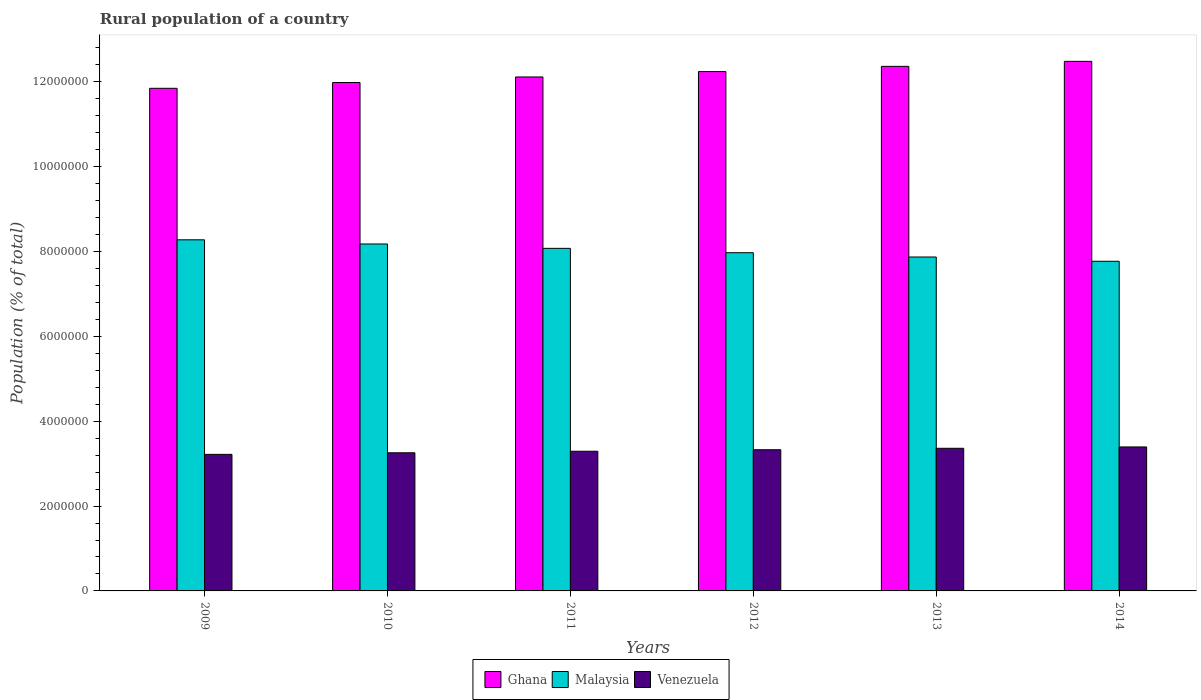How many different coloured bars are there?
Give a very brief answer. 3. How many groups of bars are there?
Ensure brevity in your answer.  6. Are the number of bars per tick equal to the number of legend labels?
Ensure brevity in your answer.  Yes. Are the number of bars on each tick of the X-axis equal?
Keep it short and to the point. Yes. How many bars are there on the 5th tick from the left?
Offer a terse response. 3. How many bars are there on the 6th tick from the right?
Provide a succinct answer. 3. What is the label of the 6th group of bars from the left?
Keep it short and to the point. 2014. What is the rural population in Venezuela in 2011?
Your answer should be compact. 3.29e+06. Across all years, what is the maximum rural population in Malaysia?
Make the answer very short. 8.28e+06. Across all years, what is the minimum rural population in Ghana?
Make the answer very short. 1.18e+07. In which year was the rural population in Malaysia maximum?
Offer a very short reply. 2009. What is the total rural population in Ghana in the graph?
Ensure brevity in your answer.  7.30e+07. What is the difference between the rural population in Ghana in 2009 and that in 2011?
Provide a short and direct response. -2.68e+05. What is the difference between the rural population in Venezuela in 2010 and the rural population in Malaysia in 2009?
Keep it short and to the point. -5.02e+06. What is the average rural population in Venezuela per year?
Provide a succinct answer. 3.31e+06. In the year 2009, what is the difference between the rural population in Venezuela and rural population in Ghana?
Make the answer very short. -8.63e+06. In how many years, is the rural population in Malaysia greater than 9600000 %?
Provide a succinct answer. 0. What is the ratio of the rural population in Venezuela in 2011 to that in 2012?
Provide a succinct answer. 0.99. What is the difference between the highest and the second highest rural population in Malaysia?
Make the answer very short. 9.82e+04. What is the difference between the highest and the lowest rural population in Ghana?
Give a very brief answer. 6.35e+05. Is the sum of the rural population in Venezuela in 2011 and 2014 greater than the maximum rural population in Malaysia across all years?
Give a very brief answer. No. What does the 3rd bar from the left in 2012 represents?
Your answer should be very brief. Venezuela. What does the 2nd bar from the right in 2009 represents?
Ensure brevity in your answer.  Malaysia. Is it the case that in every year, the sum of the rural population in Ghana and rural population in Malaysia is greater than the rural population in Venezuela?
Give a very brief answer. Yes. How many years are there in the graph?
Keep it short and to the point. 6. What is the difference between two consecutive major ticks on the Y-axis?
Keep it short and to the point. 2.00e+06. Does the graph contain any zero values?
Give a very brief answer. No. Does the graph contain grids?
Ensure brevity in your answer.  No. How many legend labels are there?
Offer a very short reply. 3. What is the title of the graph?
Provide a succinct answer. Rural population of a country. What is the label or title of the Y-axis?
Your answer should be very brief. Population (% of total). What is the Population (% of total) of Ghana in 2009?
Provide a short and direct response. 1.18e+07. What is the Population (% of total) in Malaysia in 2009?
Make the answer very short. 8.28e+06. What is the Population (% of total) in Venezuela in 2009?
Make the answer very short. 3.22e+06. What is the Population (% of total) of Ghana in 2010?
Ensure brevity in your answer.  1.20e+07. What is the Population (% of total) in Malaysia in 2010?
Provide a succinct answer. 8.18e+06. What is the Population (% of total) in Venezuela in 2010?
Make the answer very short. 3.26e+06. What is the Population (% of total) in Ghana in 2011?
Provide a succinct answer. 1.21e+07. What is the Population (% of total) of Malaysia in 2011?
Keep it short and to the point. 8.08e+06. What is the Population (% of total) in Venezuela in 2011?
Make the answer very short. 3.29e+06. What is the Population (% of total) of Ghana in 2012?
Your answer should be very brief. 1.22e+07. What is the Population (% of total) of Malaysia in 2012?
Give a very brief answer. 7.97e+06. What is the Population (% of total) of Venezuela in 2012?
Provide a short and direct response. 3.33e+06. What is the Population (% of total) of Ghana in 2013?
Keep it short and to the point. 1.24e+07. What is the Population (% of total) of Malaysia in 2013?
Your response must be concise. 7.87e+06. What is the Population (% of total) in Venezuela in 2013?
Your answer should be compact. 3.36e+06. What is the Population (% of total) in Ghana in 2014?
Offer a very short reply. 1.25e+07. What is the Population (% of total) of Malaysia in 2014?
Make the answer very short. 7.77e+06. What is the Population (% of total) in Venezuela in 2014?
Provide a short and direct response. 3.39e+06. Across all years, what is the maximum Population (% of total) in Ghana?
Offer a terse response. 1.25e+07. Across all years, what is the maximum Population (% of total) in Malaysia?
Give a very brief answer. 8.28e+06. Across all years, what is the maximum Population (% of total) in Venezuela?
Your answer should be compact. 3.39e+06. Across all years, what is the minimum Population (% of total) in Ghana?
Give a very brief answer. 1.18e+07. Across all years, what is the minimum Population (% of total) of Malaysia?
Offer a terse response. 7.77e+06. Across all years, what is the minimum Population (% of total) in Venezuela?
Your answer should be very brief. 3.22e+06. What is the total Population (% of total) in Ghana in the graph?
Your response must be concise. 7.30e+07. What is the total Population (% of total) in Malaysia in the graph?
Your answer should be very brief. 4.82e+07. What is the total Population (% of total) of Venezuela in the graph?
Make the answer very short. 1.99e+07. What is the difference between the Population (% of total) of Ghana in 2009 and that in 2010?
Keep it short and to the point. -1.36e+05. What is the difference between the Population (% of total) of Malaysia in 2009 and that in 2010?
Provide a short and direct response. 9.82e+04. What is the difference between the Population (% of total) in Venezuela in 2009 and that in 2010?
Ensure brevity in your answer.  -3.74e+04. What is the difference between the Population (% of total) in Ghana in 2009 and that in 2011?
Provide a succinct answer. -2.68e+05. What is the difference between the Population (% of total) in Malaysia in 2009 and that in 2011?
Your answer should be very brief. 2.01e+05. What is the difference between the Population (% of total) in Venezuela in 2009 and that in 2011?
Your answer should be compact. -7.38e+04. What is the difference between the Population (% of total) of Ghana in 2009 and that in 2012?
Offer a terse response. -3.95e+05. What is the difference between the Population (% of total) in Malaysia in 2009 and that in 2012?
Your answer should be compact. 3.04e+05. What is the difference between the Population (% of total) of Venezuela in 2009 and that in 2012?
Your response must be concise. -1.09e+05. What is the difference between the Population (% of total) of Ghana in 2009 and that in 2013?
Your answer should be very brief. -5.17e+05. What is the difference between the Population (% of total) in Malaysia in 2009 and that in 2013?
Your answer should be very brief. 4.06e+05. What is the difference between the Population (% of total) in Venezuela in 2009 and that in 2013?
Make the answer very short. -1.43e+05. What is the difference between the Population (% of total) in Ghana in 2009 and that in 2014?
Give a very brief answer. -6.35e+05. What is the difference between the Population (% of total) in Malaysia in 2009 and that in 2014?
Ensure brevity in your answer.  5.06e+05. What is the difference between the Population (% of total) of Venezuela in 2009 and that in 2014?
Your answer should be compact. -1.75e+05. What is the difference between the Population (% of total) of Ghana in 2010 and that in 2011?
Your answer should be compact. -1.31e+05. What is the difference between the Population (% of total) of Malaysia in 2010 and that in 2011?
Give a very brief answer. 1.03e+05. What is the difference between the Population (% of total) in Venezuela in 2010 and that in 2011?
Your response must be concise. -3.64e+04. What is the difference between the Population (% of total) in Ghana in 2010 and that in 2012?
Provide a succinct answer. -2.58e+05. What is the difference between the Population (% of total) in Malaysia in 2010 and that in 2012?
Provide a short and direct response. 2.06e+05. What is the difference between the Population (% of total) of Venezuela in 2010 and that in 2012?
Your response must be concise. -7.19e+04. What is the difference between the Population (% of total) of Ghana in 2010 and that in 2013?
Your response must be concise. -3.81e+05. What is the difference between the Population (% of total) of Malaysia in 2010 and that in 2013?
Ensure brevity in your answer.  3.07e+05. What is the difference between the Population (% of total) of Venezuela in 2010 and that in 2013?
Ensure brevity in your answer.  -1.06e+05. What is the difference between the Population (% of total) in Ghana in 2010 and that in 2014?
Your response must be concise. -4.99e+05. What is the difference between the Population (% of total) of Malaysia in 2010 and that in 2014?
Your response must be concise. 4.08e+05. What is the difference between the Population (% of total) of Venezuela in 2010 and that in 2014?
Your answer should be very brief. -1.38e+05. What is the difference between the Population (% of total) in Ghana in 2011 and that in 2012?
Provide a short and direct response. -1.27e+05. What is the difference between the Population (% of total) of Malaysia in 2011 and that in 2012?
Your answer should be very brief. 1.03e+05. What is the difference between the Population (% of total) in Venezuela in 2011 and that in 2012?
Provide a succinct answer. -3.55e+04. What is the difference between the Population (% of total) in Ghana in 2011 and that in 2013?
Provide a succinct answer. -2.50e+05. What is the difference between the Population (% of total) of Malaysia in 2011 and that in 2013?
Your answer should be very brief. 2.04e+05. What is the difference between the Population (% of total) in Venezuela in 2011 and that in 2013?
Provide a short and direct response. -6.95e+04. What is the difference between the Population (% of total) in Ghana in 2011 and that in 2014?
Make the answer very short. -3.68e+05. What is the difference between the Population (% of total) of Malaysia in 2011 and that in 2014?
Provide a short and direct response. 3.05e+05. What is the difference between the Population (% of total) in Venezuela in 2011 and that in 2014?
Make the answer very short. -1.01e+05. What is the difference between the Population (% of total) of Ghana in 2012 and that in 2013?
Your answer should be very brief. -1.23e+05. What is the difference between the Population (% of total) of Malaysia in 2012 and that in 2013?
Your response must be concise. 1.02e+05. What is the difference between the Population (% of total) of Venezuela in 2012 and that in 2013?
Offer a very short reply. -3.40e+04. What is the difference between the Population (% of total) in Ghana in 2012 and that in 2014?
Give a very brief answer. -2.41e+05. What is the difference between the Population (% of total) in Malaysia in 2012 and that in 2014?
Keep it short and to the point. 2.02e+05. What is the difference between the Population (% of total) of Venezuela in 2012 and that in 2014?
Offer a very short reply. -6.60e+04. What is the difference between the Population (% of total) of Ghana in 2013 and that in 2014?
Offer a very short reply. -1.18e+05. What is the difference between the Population (% of total) in Malaysia in 2013 and that in 2014?
Your answer should be compact. 1.00e+05. What is the difference between the Population (% of total) of Venezuela in 2013 and that in 2014?
Your answer should be compact. -3.20e+04. What is the difference between the Population (% of total) of Ghana in 2009 and the Population (% of total) of Malaysia in 2010?
Provide a short and direct response. 3.67e+06. What is the difference between the Population (% of total) in Ghana in 2009 and the Population (% of total) in Venezuela in 2010?
Keep it short and to the point. 8.59e+06. What is the difference between the Population (% of total) in Malaysia in 2009 and the Population (% of total) in Venezuela in 2010?
Your response must be concise. 5.02e+06. What is the difference between the Population (% of total) in Ghana in 2009 and the Population (% of total) in Malaysia in 2011?
Give a very brief answer. 3.77e+06. What is the difference between the Population (% of total) in Ghana in 2009 and the Population (% of total) in Venezuela in 2011?
Ensure brevity in your answer.  8.56e+06. What is the difference between the Population (% of total) in Malaysia in 2009 and the Population (% of total) in Venezuela in 2011?
Give a very brief answer. 4.98e+06. What is the difference between the Population (% of total) of Ghana in 2009 and the Population (% of total) of Malaysia in 2012?
Offer a very short reply. 3.88e+06. What is the difference between the Population (% of total) in Ghana in 2009 and the Population (% of total) in Venezuela in 2012?
Your answer should be very brief. 8.52e+06. What is the difference between the Population (% of total) in Malaysia in 2009 and the Population (% of total) in Venezuela in 2012?
Your answer should be very brief. 4.95e+06. What is the difference between the Population (% of total) of Ghana in 2009 and the Population (% of total) of Malaysia in 2013?
Your answer should be compact. 3.98e+06. What is the difference between the Population (% of total) of Ghana in 2009 and the Population (% of total) of Venezuela in 2013?
Make the answer very short. 8.49e+06. What is the difference between the Population (% of total) of Malaysia in 2009 and the Population (% of total) of Venezuela in 2013?
Keep it short and to the point. 4.92e+06. What is the difference between the Population (% of total) of Ghana in 2009 and the Population (% of total) of Malaysia in 2014?
Offer a terse response. 4.08e+06. What is the difference between the Population (% of total) of Ghana in 2009 and the Population (% of total) of Venezuela in 2014?
Your response must be concise. 8.45e+06. What is the difference between the Population (% of total) of Malaysia in 2009 and the Population (% of total) of Venezuela in 2014?
Offer a terse response. 4.88e+06. What is the difference between the Population (% of total) of Ghana in 2010 and the Population (% of total) of Malaysia in 2011?
Your answer should be very brief. 3.91e+06. What is the difference between the Population (% of total) of Ghana in 2010 and the Population (% of total) of Venezuela in 2011?
Offer a terse response. 8.69e+06. What is the difference between the Population (% of total) of Malaysia in 2010 and the Population (% of total) of Venezuela in 2011?
Give a very brief answer. 4.89e+06. What is the difference between the Population (% of total) of Ghana in 2010 and the Population (% of total) of Malaysia in 2012?
Provide a succinct answer. 4.01e+06. What is the difference between the Population (% of total) of Ghana in 2010 and the Population (% of total) of Venezuela in 2012?
Your answer should be very brief. 8.66e+06. What is the difference between the Population (% of total) of Malaysia in 2010 and the Population (% of total) of Venezuela in 2012?
Your answer should be very brief. 4.85e+06. What is the difference between the Population (% of total) of Ghana in 2010 and the Population (% of total) of Malaysia in 2013?
Provide a short and direct response. 4.11e+06. What is the difference between the Population (% of total) in Ghana in 2010 and the Population (% of total) in Venezuela in 2013?
Your response must be concise. 8.62e+06. What is the difference between the Population (% of total) in Malaysia in 2010 and the Population (% of total) in Venezuela in 2013?
Keep it short and to the point. 4.82e+06. What is the difference between the Population (% of total) of Ghana in 2010 and the Population (% of total) of Malaysia in 2014?
Offer a terse response. 4.21e+06. What is the difference between the Population (% of total) of Ghana in 2010 and the Population (% of total) of Venezuela in 2014?
Your answer should be very brief. 8.59e+06. What is the difference between the Population (% of total) in Malaysia in 2010 and the Population (% of total) in Venezuela in 2014?
Offer a very short reply. 4.78e+06. What is the difference between the Population (% of total) in Ghana in 2011 and the Population (% of total) in Malaysia in 2012?
Give a very brief answer. 4.14e+06. What is the difference between the Population (% of total) in Ghana in 2011 and the Population (% of total) in Venezuela in 2012?
Offer a terse response. 8.79e+06. What is the difference between the Population (% of total) in Malaysia in 2011 and the Population (% of total) in Venezuela in 2012?
Your answer should be very brief. 4.75e+06. What is the difference between the Population (% of total) of Ghana in 2011 and the Population (% of total) of Malaysia in 2013?
Keep it short and to the point. 4.24e+06. What is the difference between the Population (% of total) in Ghana in 2011 and the Population (% of total) in Venezuela in 2013?
Make the answer very short. 8.75e+06. What is the difference between the Population (% of total) of Malaysia in 2011 and the Population (% of total) of Venezuela in 2013?
Offer a terse response. 4.71e+06. What is the difference between the Population (% of total) of Ghana in 2011 and the Population (% of total) of Malaysia in 2014?
Offer a very short reply. 4.35e+06. What is the difference between the Population (% of total) of Ghana in 2011 and the Population (% of total) of Venezuela in 2014?
Offer a terse response. 8.72e+06. What is the difference between the Population (% of total) of Malaysia in 2011 and the Population (% of total) of Venezuela in 2014?
Provide a succinct answer. 4.68e+06. What is the difference between the Population (% of total) in Ghana in 2012 and the Population (% of total) in Malaysia in 2013?
Offer a terse response. 4.37e+06. What is the difference between the Population (% of total) of Ghana in 2012 and the Population (% of total) of Venezuela in 2013?
Provide a short and direct response. 8.88e+06. What is the difference between the Population (% of total) of Malaysia in 2012 and the Population (% of total) of Venezuela in 2013?
Make the answer very short. 4.61e+06. What is the difference between the Population (% of total) in Ghana in 2012 and the Population (% of total) in Malaysia in 2014?
Your response must be concise. 4.47e+06. What is the difference between the Population (% of total) in Ghana in 2012 and the Population (% of total) in Venezuela in 2014?
Make the answer very short. 8.85e+06. What is the difference between the Population (% of total) of Malaysia in 2012 and the Population (% of total) of Venezuela in 2014?
Your answer should be very brief. 4.58e+06. What is the difference between the Population (% of total) of Ghana in 2013 and the Population (% of total) of Malaysia in 2014?
Offer a very short reply. 4.60e+06. What is the difference between the Population (% of total) of Ghana in 2013 and the Population (% of total) of Venezuela in 2014?
Make the answer very short. 8.97e+06. What is the difference between the Population (% of total) of Malaysia in 2013 and the Population (% of total) of Venezuela in 2014?
Your response must be concise. 4.48e+06. What is the average Population (% of total) of Ghana per year?
Provide a succinct answer. 1.22e+07. What is the average Population (% of total) in Malaysia per year?
Give a very brief answer. 8.03e+06. What is the average Population (% of total) in Venezuela per year?
Offer a very short reply. 3.31e+06. In the year 2009, what is the difference between the Population (% of total) of Ghana and Population (% of total) of Malaysia?
Offer a very short reply. 3.57e+06. In the year 2009, what is the difference between the Population (% of total) of Ghana and Population (% of total) of Venezuela?
Your response must be concise. 8.63e+06. In the year 2009, what is the difference between the Population (% of total) in Malaysia and Population (% of total) in Venezuela?
Ensure brevity in your answer.  5.06e+06. In the year 2010, what is the difference between the Population (% of total) of Ghana and Population (% of total) of Malaysia?
Offer a terse response. 3.81e+06. In the year 2010, what is the difference between the Population (% of total) in Ghana and Population (% of total) in Venezuela?
Offer a terse response. 8.73e+06. In the year 2010, what is the difference between the Population (% of total) of Malaysia and Population (% of total) of Venezuela?
Offer a terse response. 4.92e+06. In the year 2011, what is the difference between the Population (% of total) in Ghana and Population (% of total) in Malaysia?
Make the answer very short. 4.04e+06. In the year 2011, what is the difference between the Population (% of total) in Ghana and Population (% of total) in Venezuela?
Offer a very short reply. 8.82e+06. In the year 2011, what is the difference between the Population (% of total) of Malaysia and Population (% of total) of Venezuela?
Provide a short and direct response. 4.78e+06. In the year 2012, what is the difference between the Population (% of total) of Ghana and Population (% of total) of Malaysia?
Your response must be concise. 4.27e+06. In the year 2012, what is the difference between the Population (% of total) in Ghana and Population (% of total) in Venezuela?
Offer a very short reply. 8.92e+06. In the year 2012, what is the difference between the Population (% of total) of Malaysia and Population (% of total) of Venezuela?
Keep it short and to the point. 4.65e+06. In the year 2013, what is the difference between the Population (% of total) of Ghana and Population (% of total) of Malaysia?
Provide a short and direct response. 4.49e+06. In the year 2013, what is the difference between the Population (% of total) of Ghana and Population (% of total) of Venezuela?
Your answer should be compact. 9.00e+06. In the year 2013, what is the difference between the Population (% of total) in Malaysia and Population (% of total) in Venezuela?
Your response must be concise. 4.51e+06. In the year 2014, what is the difference between the Population (% of total) in Ghana and Population (% of total) in Malaysia?
Your answer should be compact. 4.71e+06. In the year 2014, what is the difference between the Population (% of total) in Ghana and Population (% of total) in Venezuela?
Give a very brief answer. 9.09e+06. In the year 2014, what is the difference between the Population (% of total) in Malaysia and Population (% of total) in Venezuela?
Give a very brief answer. 4.38e+06. What is the ratio of the Population (% of total) in Malaysia in 2009 to that in 2010?
Your answer should be very brief. 1.01. What is the ratio of the Population (% of total) of Ghana in 2009 to that in 2011?
Keep it short and to the point. 0.98. What is the ratio of the Population (% of total) in Malaysia in 2009 to that in 2011?
Provide a short and direct response. 1.02. What is the ratio of the Population (% of total) in Venezuela in 2009 to that in 2011?
Your answer should be very brief. 0.98. What is the ratio of the Population (% of total) in Ghana in 2009 to that in 2012?
Offer a terse response. 0.97. What is the ratio of the Population (% of total) in Malaysia in 2009 to that in 2012?
Your response must be concise. 1.04. What is the ratio of the Population (% of total) in Venezuela in 2009 to that in 2012?
Your response must be concise. 0.97. What is the ratio of the Population (% of total) in Ghana in 2009 to that in 2013?
Offer a very short reply. 0.96. What is the ratio of the Population (% of total) in Malaysia in 2009 to that in 2013?
Offer a terse response. 1.05. What is the ratio of the Population (% of total) of Venezuela in 2009 to that in 2013?
Offer a very short reply. 0.96. What is the ratio of the Population (% of total) in Ghana in 2009 to that in 2014?
Keep it short and to the point. 0.95. What is the ratio of the Population (% of total) of Malaysia in 2009 to that in 2014?
Your answer should be compact. 1.07. What is the ratio of the Population (% of total) in Venezuela in 2009 to that in 2014?
Keep it short and to the point. 0.95. What is the ratio of the Population (% of total) of Malaysia in 2010 to that in 2011?
Provide a short and direct response. 1.01. What is the ratio of the Population (% of total) in Venezuela in 2010 to that in 2011?
Make the answer very short. 0.99. What is the ratio of the Population (% of total) in Ghana in 2010 to that in 2012?
Your answer should be very brief. 0.98. What is the ratio of the Population (% of total) in Malaysia in 2010 to that in 2012?
Make the answer very short. 1.03. What is the ratio of the Population (% of total) of Venezuela in 2010 to that in 2012?
Provide a succinct answer. 0.98. What is the ratio of the Population (% of total) in Ghana in 2010 to that in 2013?
Your answer should be compact. 0.97. What is the ratio of the Population (% of total) in Malaysia in 2010 to that in 2013?
Keep it short and to the point. 1.04. What is the ratio of the Population (% of total) in Venezuela in 2010 to that in 2013?
Your answer should be compact. 0.97. What is the ratio of the Population (% of total) in Malaysia in 2010 to that in 2014?
Your response must be concise. 1.05. What is the ratio of the Population (% of total) of Venezuela in 2010 to that in 2014?
Your answer should be very brief. 0.96. What is the ratio of the Population (% of total) of Malaysia in 2011 to that in 2012?
Keep it short and to the point. 1.01. What is the ratio of the Population (% of total) in Venezuela in 2011 to that in 2012?
Give a very brief answer. 0.99. What is the ratio of the Population (% of total) of Ghana in 2011 to that in 2013?
Offer a terse response. 0.98. What is the ratio of the Population (% of total) in Malaysia in 2011 to that in 2013?
Your answer should be compact. 1.03. What is the ratio of the Population (% of total) in Venezuela in 2011 to that in 2013?
Make the answer very short. 0.98. What is the ratio of the Population (% of total) of Ghana in 2011 to that in 2014?
Ensure brevity in your answer.  0.97. What is the ratio of the Population (% of total) in Malaysia in 2011 to that in 2014?
Make the answer very short. 1.04. What is the ratio of the Population (% of total) in Venezuela in 2011 to that in 2014?
Make the answer very short. 0.97. What is the ratio of the Population (% of total) of Ghana in 2012 to that in 2013?
Offer a terse response. 0.99. What is the ratio of the Population (% of total) in Malaysia in 2012 to that in 2013?
Provide a short and direct response. 1.01. What is the ratio of the Population (% of total) of Ghana in 2012 to that in 2014?
Your answer should be very brief. 0.98. What is the ratio of the Population (% of total) in Malaysia in 2012 to that in 2014?
Your answer should be very brief. 1.03. What is the ratio of the Population (% of total) in Venezuela in 2012 to that in 2014?
Your answer should be compact. 0.98. What is the ratio of the Population (% of total) of Ghana in 2013 to that in 2014?
Keep it short and to the point. 0.99. What is the ratio of the Population (% of total) of Malaysia in 2013 to that in 2014?
Offer a terse response. 1.01. What is the ratio of the Population (% of total) of Venezuela in 2013 to that in 2014?
Provide a short and direct response. 0.99. What is the difference between the highest and the second highest Population (% of total) of Ghana?
Give a very brief answer. 1.18e+05. What is the difference between the highest and the second highest Population (% of total) in Malaysia?
Keep it short and to the point. 9.82e+04. What is the difference between the highest and the second highest Population (% of total) of Venezuela?
Make the answer very short. 3.20e+04. What is the difference between the highest and the lowest Population (% of total) in Ghana?
Give a very brief answer. 6.35e+05. What is the difference between the highest and the lowest Population (% of total) in Malaysia?
Your answer should be very brief. 5.06e+05. What is the difference between the highest and the lowest Population (% of total) in Venezuela?
Offer a terse response. 1.75e+05. 